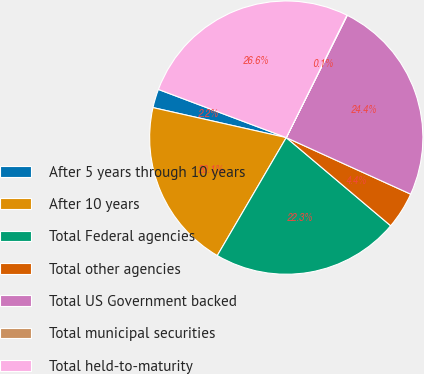Convert chart to OTSL. <chart><loc_0><loc_0><loc_500><loc_500><pie_chart><fcel>After 5 years through 10 years<fcel>After 10 years<fcel>Total Federal agencies<fcel>Total other agencies<fcel>Total US Government backed<fcel>Total municipal securities<fcel>Total held-to-maturity<nl><fcel>2.21%<fcel>20.1%<fcel>22.26%<fcel>4.37%<fcel>24.42%<fcel>0.05%<fcel>26.58%<nl></chart> 